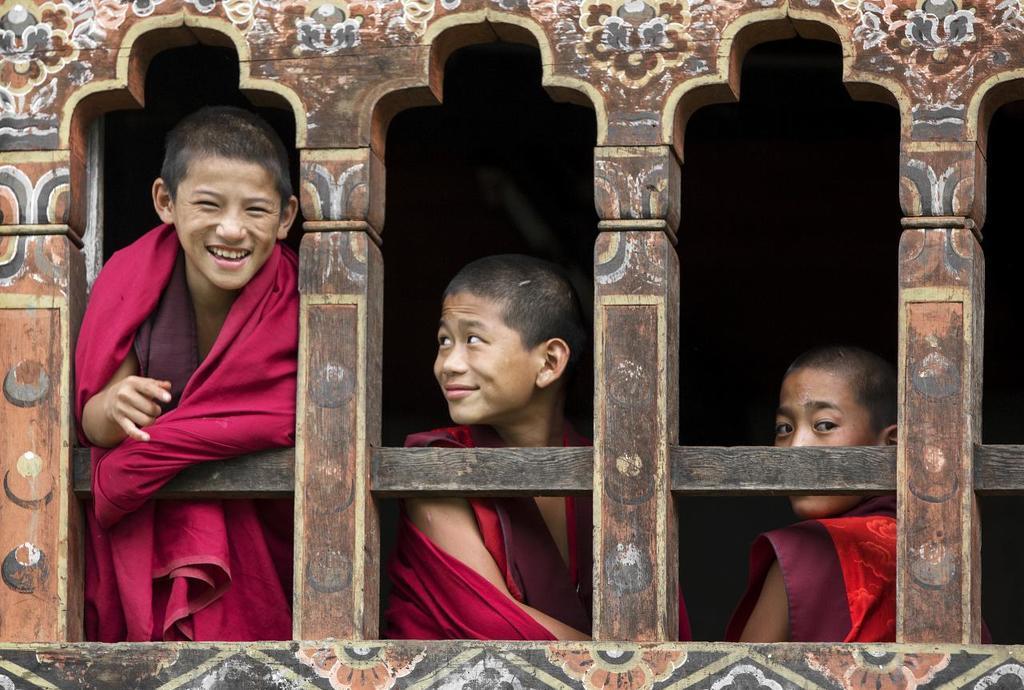Describe this image in one or two sentences. In this picture we can see three boys, windows and in the background it is dark. 